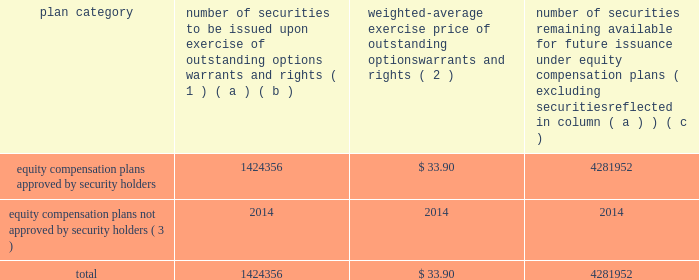Equity compensation plan information the table presents the equity securities available for issuance under our equity compensation plans as of december 31 , 2015 .
Equity compensation plan information plan category number of securities to be issued upon exercise of outstanding options , warrants and rights ( 1 ) weighted-average exercise price of outstanding options , warrants and rights ( 2 ) number of securities remaining available for future issuance under equity compensation plans ( excluding securities reflected in column ( a ) ) ( a ) ( b ) ( c ) equity compensation plans approved by security holders 1424356 $ 33.90 4281952 equity compensation plans not approved by security holders ( 3 ) 2014 2014 2014 .
( 1 ) includes grants made under the huntington ingalls industries , inc .
2012 long-term incentive stock plan ( the "2012 plan" ) , which was approved by our stockholders on may 2 , 2012 , and the huntington ingalls industries , inc .
2011 long-term incentive stock plan ( the "2011 plan" ) , which was approved by the sole stockholder of hii prior to its spin-off from northrop grumman corporation .
Of these shares , 533397 were subject to stock options and 54191 were stock rights granted under the 2011 plan .
In addition , this number includes 35553 stock rights , 10279 restricted stock rights , and 790936 restricted performance stock rights granted under the 2012 plan , assuming target performance achievement .
( 2 ) this is the weighted average exercise price of the 533397 outstanding stock options only .
( 3 ) there are no awards made under plans not approved by security holders .
Item 13 .
Certain relationships and related transactions , and director independence information as to certain relationships and related transactions and director independence will be incorporated herein by reference to the proxy statement for our 2016 annual meeting of stockholders , to be filed within 120 days after the end of the company 2019s fiscal year .
Item 14 .
Principal accountant fees and services information as to principal accountant fees and services will be incorporated herein by reference to the proxy statement for our 2016 annual meeting of stockholders , to be filed within 120 days after the end of the company 2019s fiscal year. .
What portion of the equity compensation plans approved by security holders is to be issued upon exercise of outstanding options warrants and rights? 
Computations: (1424356 / (1424356 + 4281952))
Answer: 0.24961. 